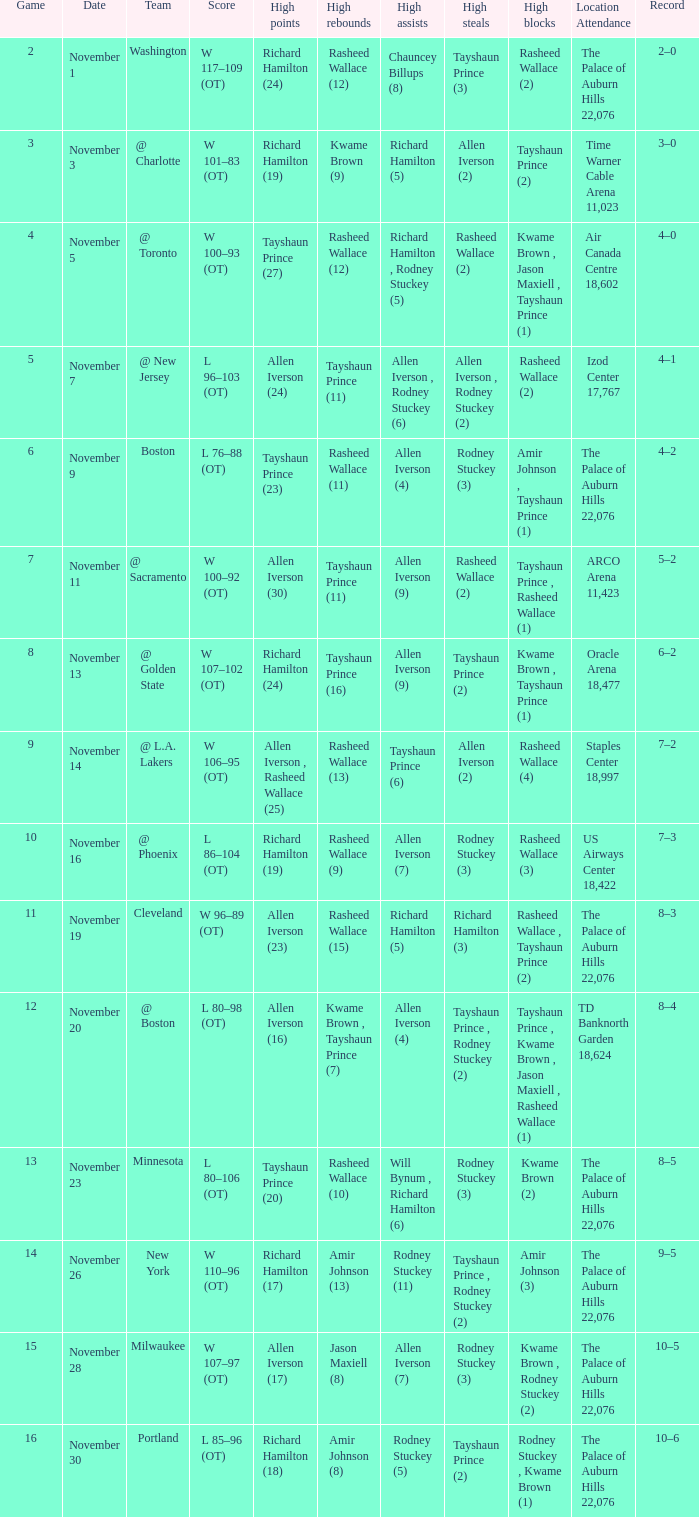What is High Points, when Game is less than 10, and when High Assists is "Chauncey Billups (8)"? Richard Hamilton (24). 